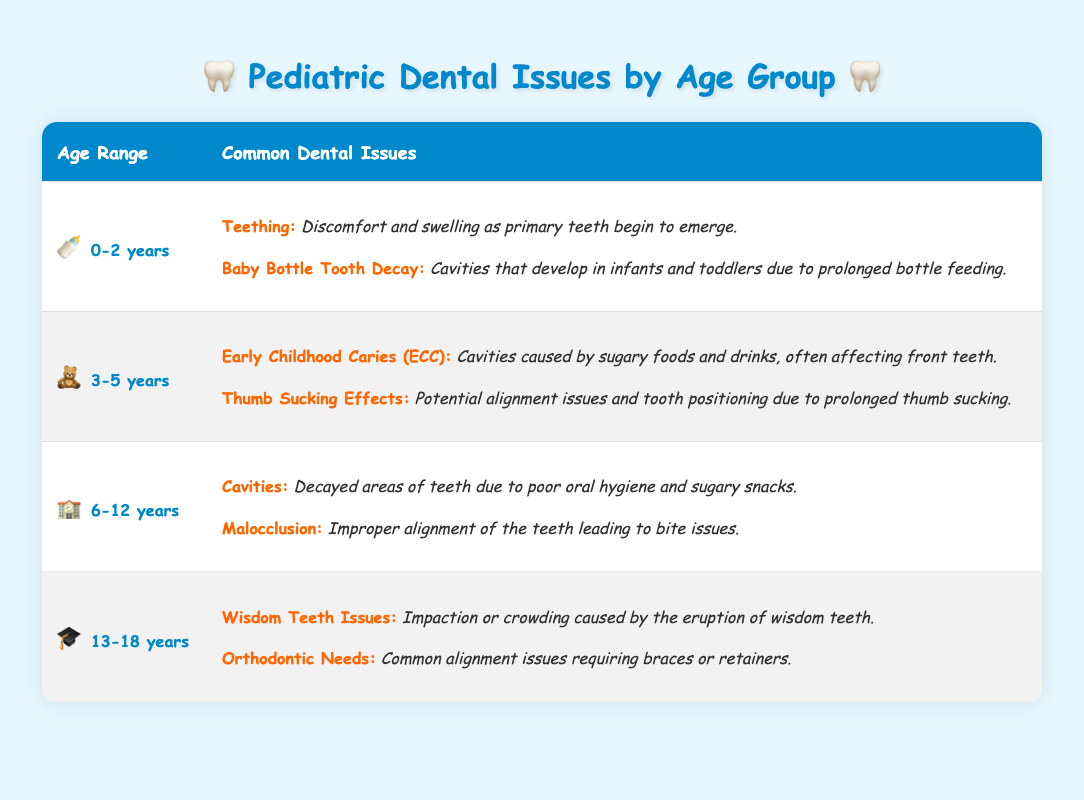What are the common dental issues for children aged 0-2 years? The table lists two common dental issues for the 0-2 years age group: "Teething," which involves discomfort and swelling as primary teeth begin to emerge, and "Baby Bottle Tooth Decay," which refers to cavities developing in infants and toddlers due to prolonged bottle feeding.
Answer: Teething and Baby Bottle Tooth Decay Is it true that children aged 3-5 years may experience early childhood caries? According to the table, "Early Childhood Caries (ECC)" is indeed listed as a common issue for the 3-5 years age group, which is caused by sugary foods and drinks affecting the front teeth.
Answer: Yes How many common dental issues are listed for children aged 6-12 years? The table indicates that there are two common dental issues for the 6-12 years age group: "Cavities" and "Malocclusion." Hence, the count is simply derived from the number of issues presented.
Answer: 2 What age group has issues related to wisdom teeth? The table specifies that "Wisdom Teeth Issues" are a common dental issue for the age group of 13-18 years, indicating that these issues arise due to the eruption of wisdom teeth and potential crowding.
Answer: 13-18 years Combine the number of issues for ages 0-2 years and 6-12 years. What is the total? For the age group of 0-2 years, there are 2 common dental issues (Teething and Baby Bottle Tooth Decay), and for the age group of 6-12 years, there are also 2 common issues (Cavities and Malocclusion), making the total 2 + 2 = 4.
Answer: 4 What is the common dental issue for children aged 3-5 years related to thumb sucking? The table states that "Thumb Sucking Effects" is a common issue for 3-5 years old. This condition can lead to potential alignment issues and problems with tooth positioning due to extended thumb sucking.
Answer: Thumb Sucking Effects Are cavities considered a common dental issue for children older than 5 years? The table shows that cavities are a common issue for the age group of 6-12 years, thus confirming that cavities affect children older than 5 years.
Answer: Yes Which age group faces orthodontic needs? The table indicates that "Orthodontic Needs" is a common concern for the 13-18 years age group, necessitating treatments such as braces or retainers for alignment issues.
Answer: 13-18 years 